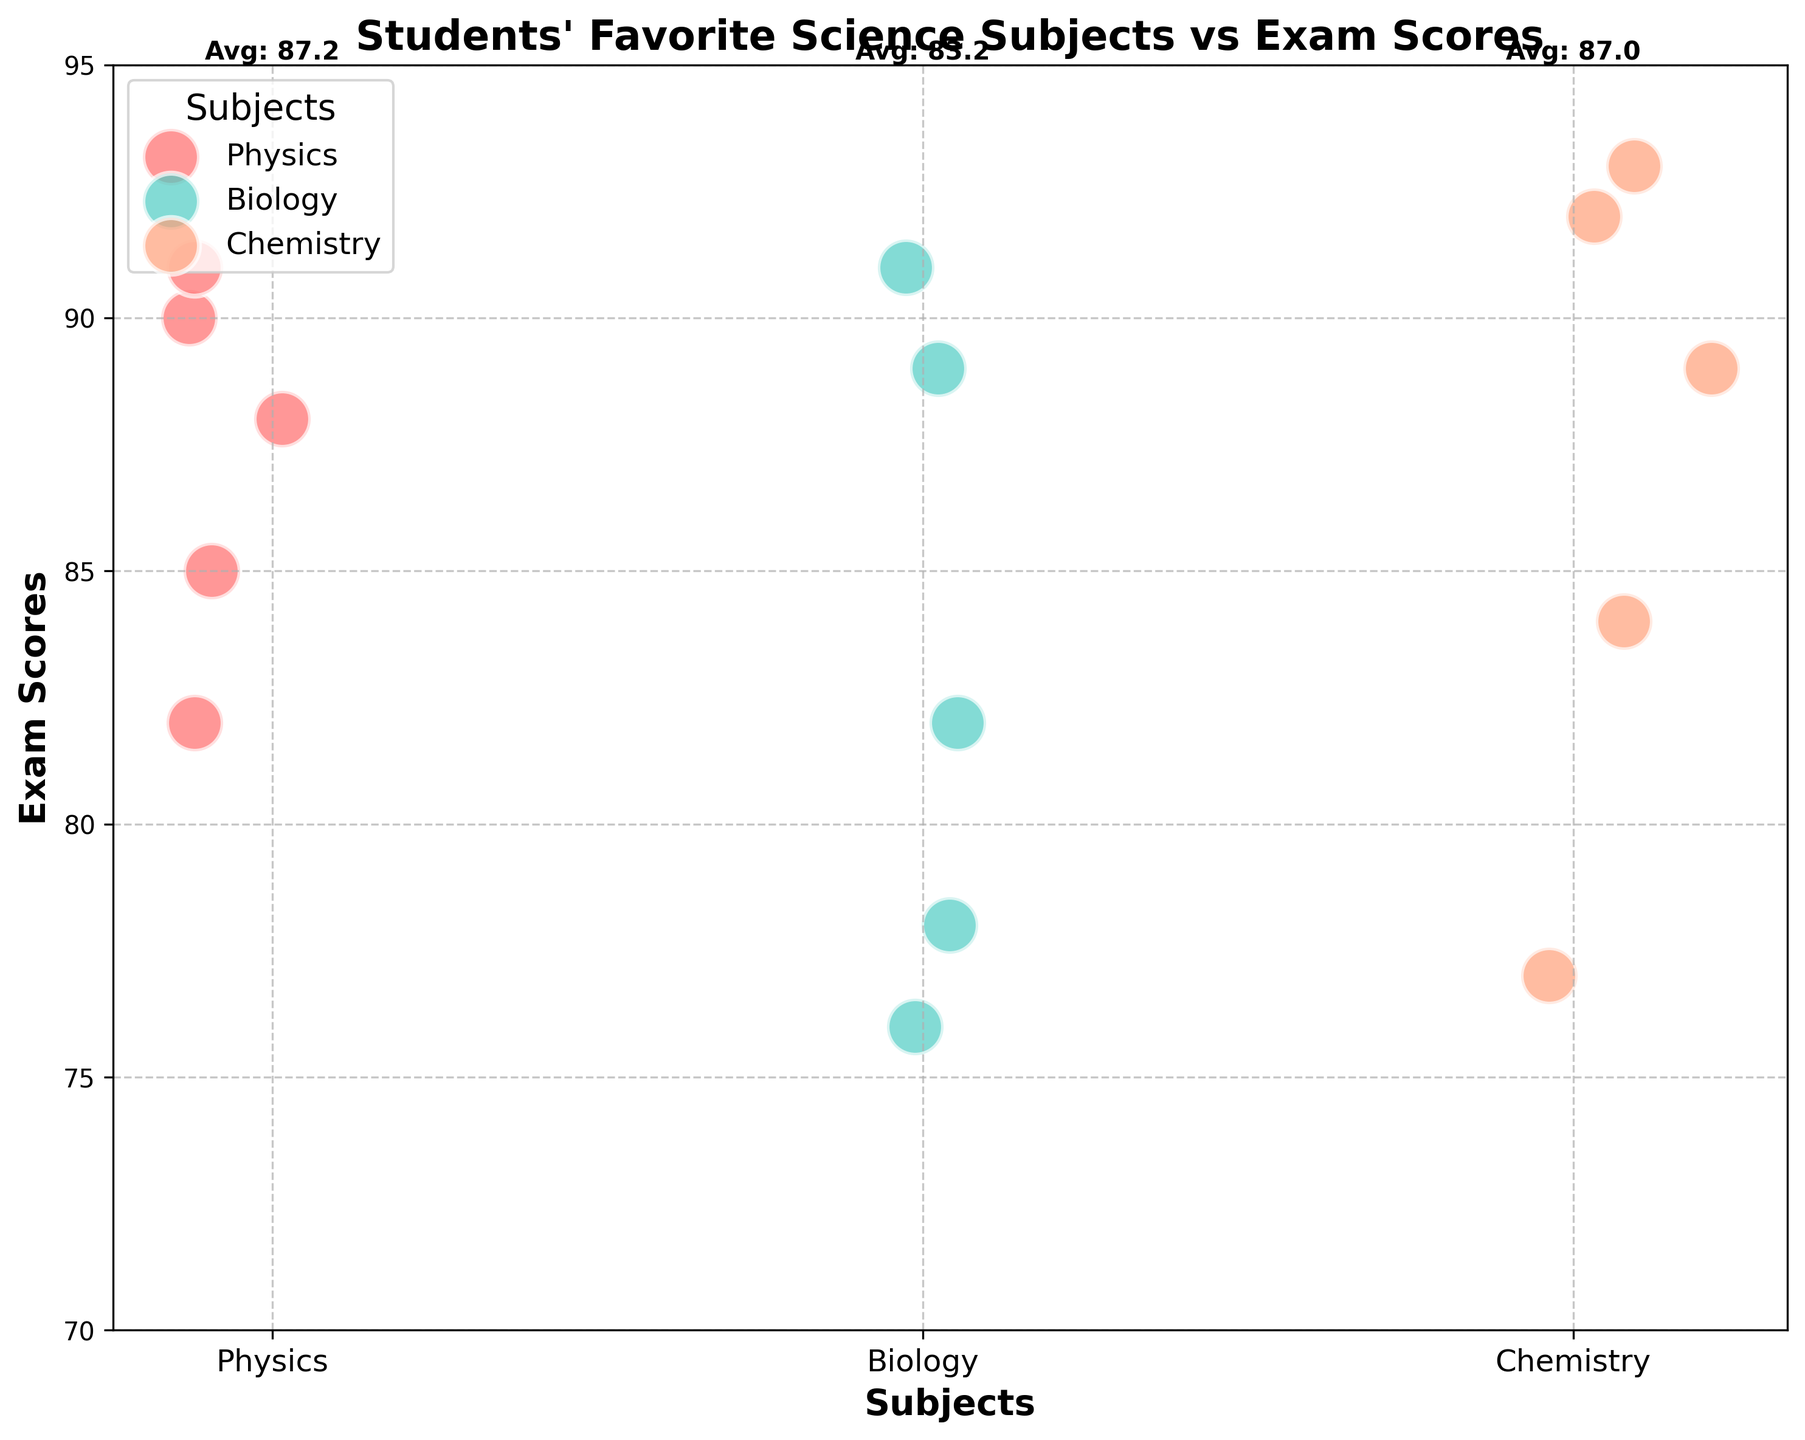What is the title of the bubble chart? The title of the chart can be directly read at the top of the figure.
Answer: Students' Favorite Science Subjects vs Exam Scores What is the range of the exam scores shown on the y-axis? The y-axis range can be observed by looking at the minimum and maximum labels on the y-axis.
Answer: 70 to 95 How are subjects represented in the bubble chart? Subjects are represented by different colors in the chart. Each subject has a distinct color for its bubbles.
Answer: Different colors Which subject has the highest average exam score based on the annotations? The annotations at the top of each subject cluster show the average scores for each subject. By comparing these annotations, we can identify the highest average.
Answer: Chemistry Count the number of students whose favorite subject is Physics. The number of students for each subject is reflected in the number of bubbles. Count the bubbles labeled as Physics.
Answer: 5 What is the average score for Biology based on the visualization? The average score for Biology can be found in the text annotation just above the Biology section of the chart.
Answer: 83.2 Compare the highest individual scores across all subjects. Which subject has the highest individual score, and what is it? By looking at the highest bubble in each subject cluster, we can identify which one reaches the highest y-axis value.
Answer: Chemistry, 93 Which subject has the smallest representation in terms of student numbers? The subject with the fewest bubbles represents the smallest student group. This can be seen by comparing the number of bubbles for each subject.
Answer: Chemistry What is the color used to represent Biology, and how many Biology students scored above 80? Observe the color legend for Biology and count the bubbles in the Biology section that are positioned above the y-axis value of 80.
Answer: Cyan, 4 How does the distribution of scores for Physics compare to Biology? Compare the spread and central tendency of the bubbles in the Physics cluster to those in the Biology cluster to understand how widely the scores are distributed for each subject.
Answer: Physics scores are more tightly clustered around higher values, while Biology scores are more spread out 